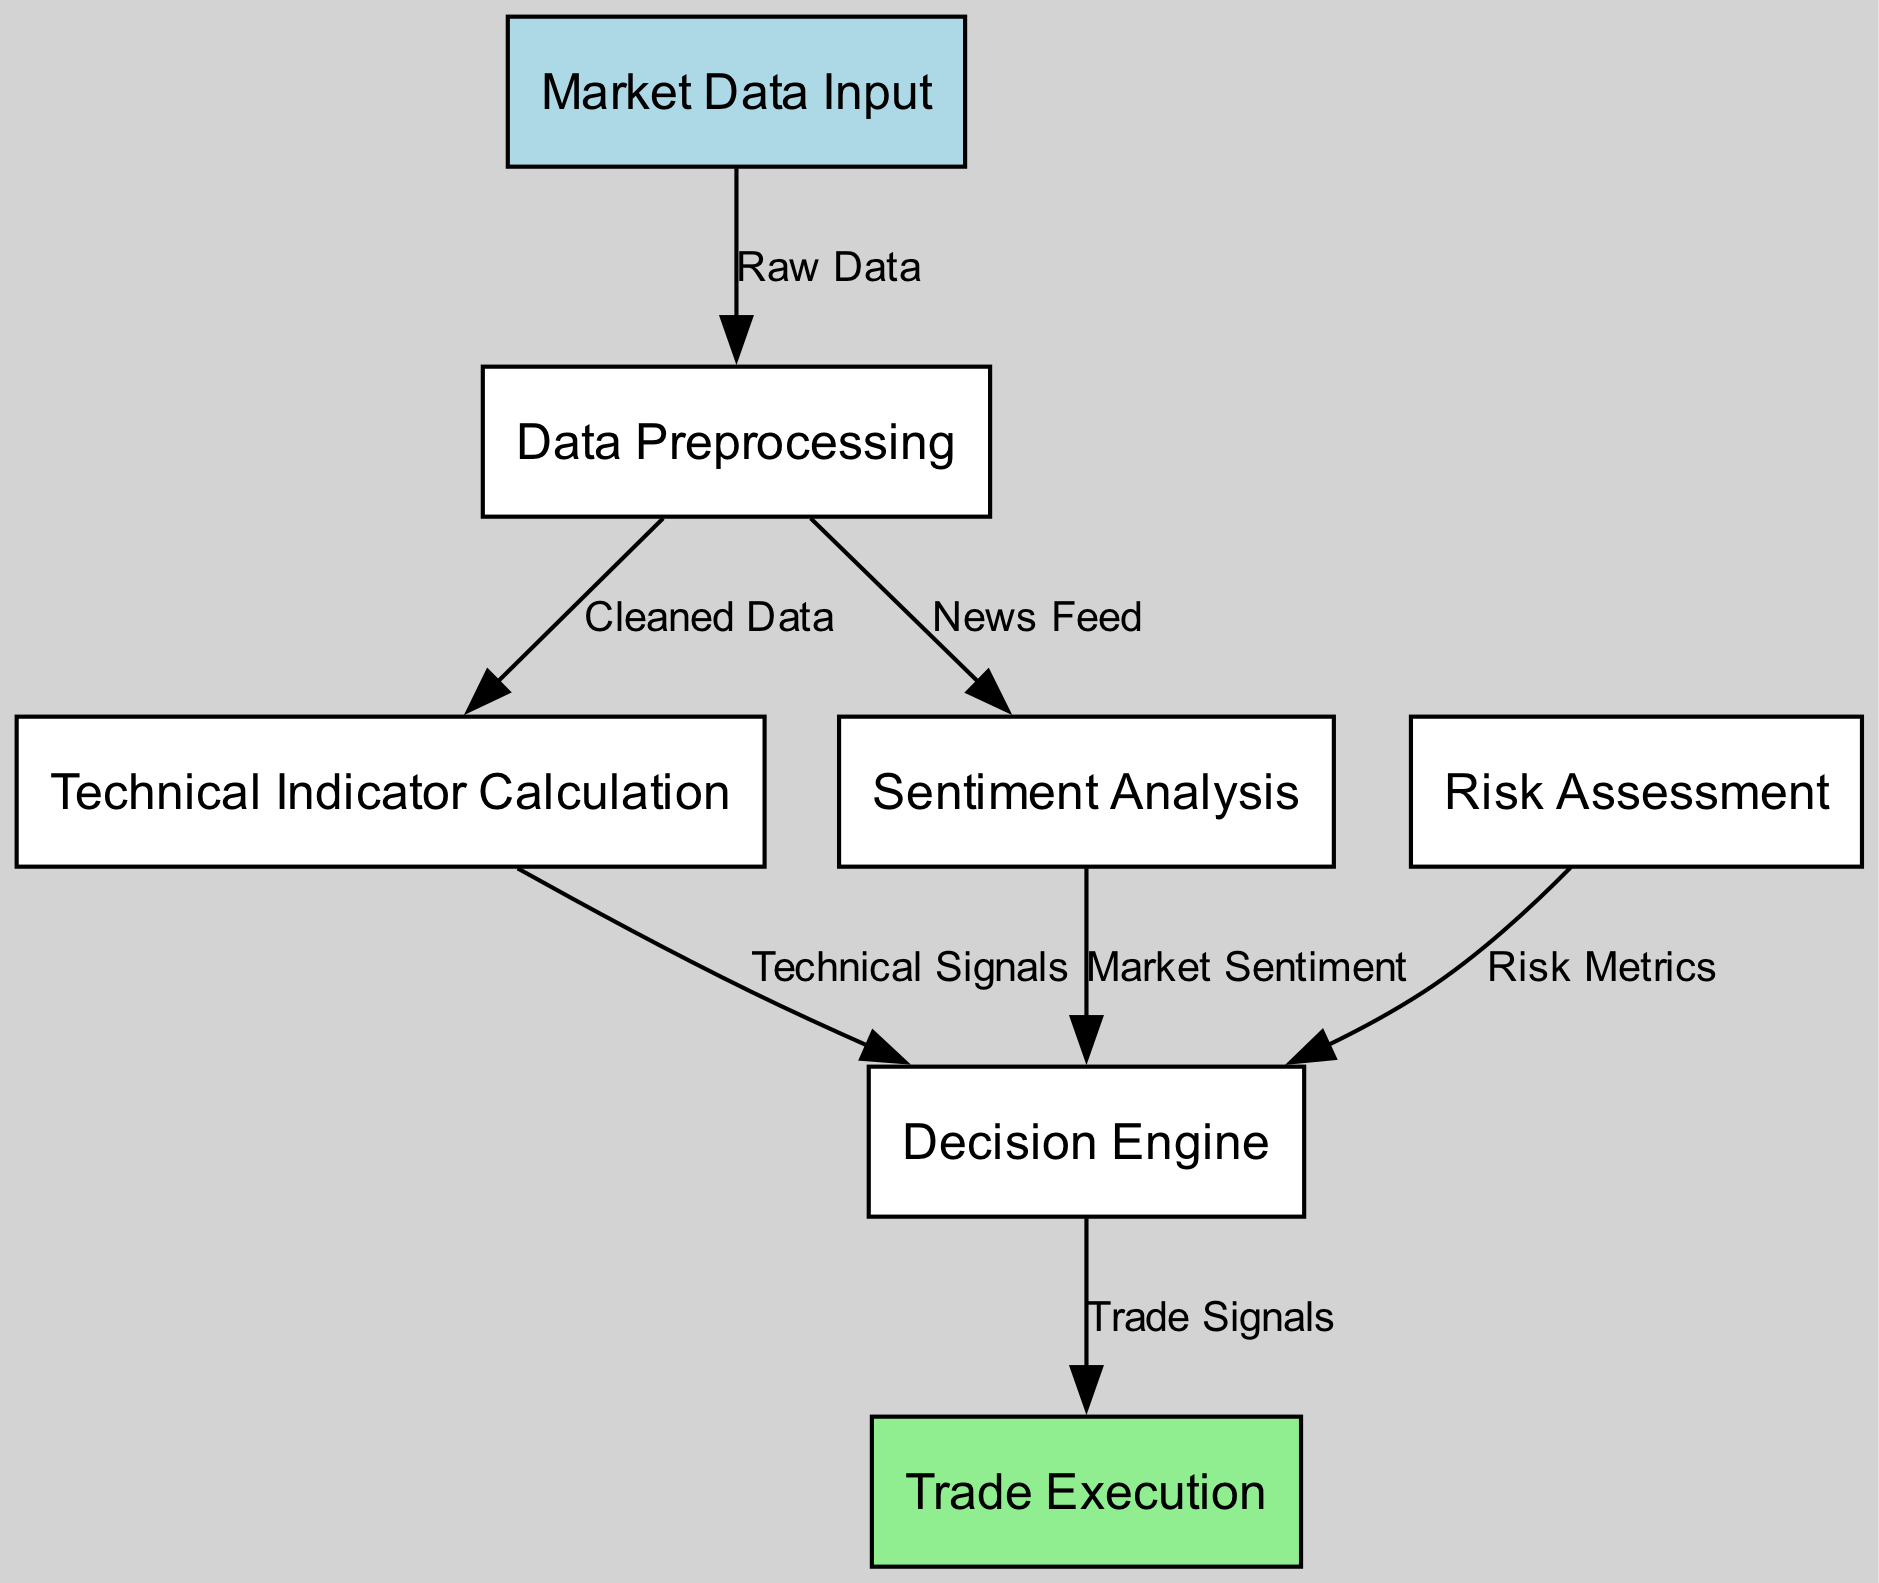What is the first node in the diagram? The first node is "Market Data Input," and it is identified as node "1" which serves as the starting point of the automated trading algorithm.
Answer: Market Data Input How many nodes are present in the diagram? There are seven nodes in the diagram: Market Data Input, Data Preprocessing, Technical Indicator Calculation, Sentiment Analysis, Risk Assessment, Decision Engine, and Trade Execution.
Answer: Seven What type of data is sent from 'Market Data Input' to 'Data Preprocessing'? The data sent is labeled as "Raw Data." This edge indicates that the market data input will undergo preprocessing before further analysis.
Answer: Raw Data Which node receives data from both 'Technical Indicator Calculation' and 'Sentiment Analysis'? The "Decision Engine" node receives data from both the Technical Indicator Calculation and Sentiment Analysis nodes. This indicates that it combines multiple data sources to arrive at a trading decision.
Answer: Decision Engine How many edges connect to the 'Decision Engine'? There are three edges connecting to the Decision Engine, each coming from Technical Indicator Calculation, Sentiment Analysis, and Risk Assessment, indicating the multiple inputs it uses to make a decision.
Answer: Three What influences the 'Trade Execution' node? The 'Trade Execution' node is influenced by the output labeled as "Trade Signals" from the Decision Engine, meaning that the trade decisions made will directly affect the execution of trades in the market.
Answer: Trade Signals Which node provides inputs to both 'Technical Indicator Calculation' and 'Sentiment Analysis'? The 'Data Preprocessing' node provides inputs to both the Technical Indicator Calculation, which uses cleaned market data, and the Sentiment Analysis, which utilizes the news feed derived from the data preprocessing stage.
Answer: Data Preprocessing What does the 'Risk Assessment' node contribute to the 'Decision Engine'? The 'Risk Assessment' node contributes "Risk Metrics" to the Decision Engine, allowing the algorithm to incorporate risk management into its trading strategies.
Answer: Risk Metrics What node is responsible for executing trades in the algorithm? The "Trade Execution" node is responsible for executing trades, as indicated by its final position in the flow of the diagram, receiving processed trade signals from the Decision Engine.
Answer: Trade Execution 